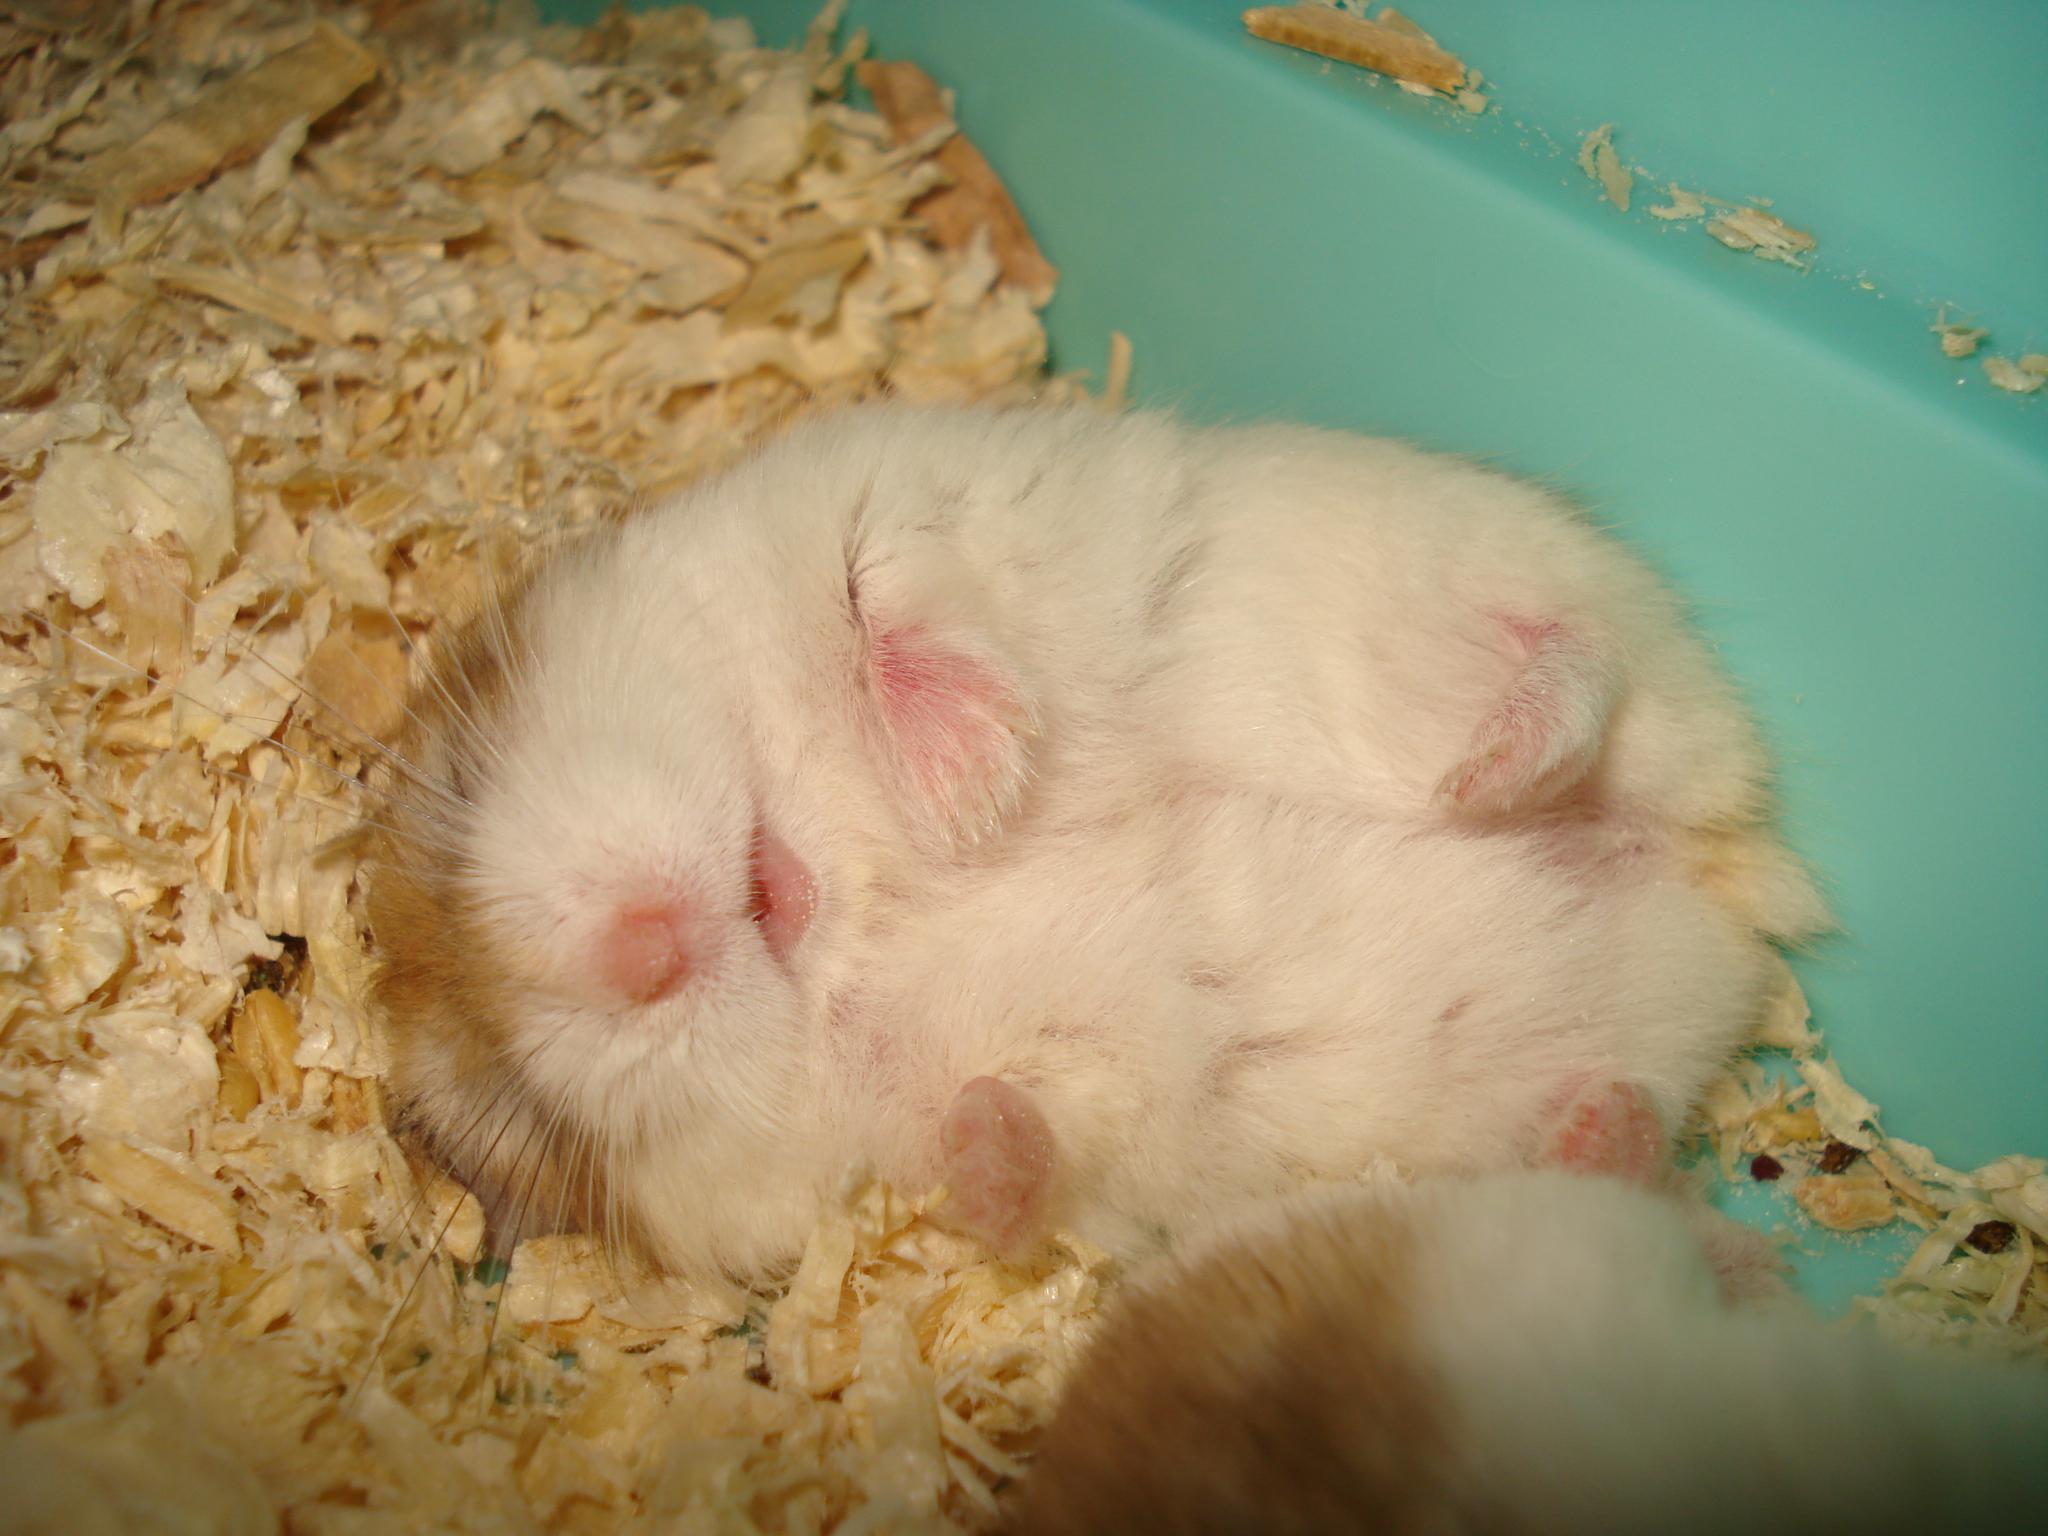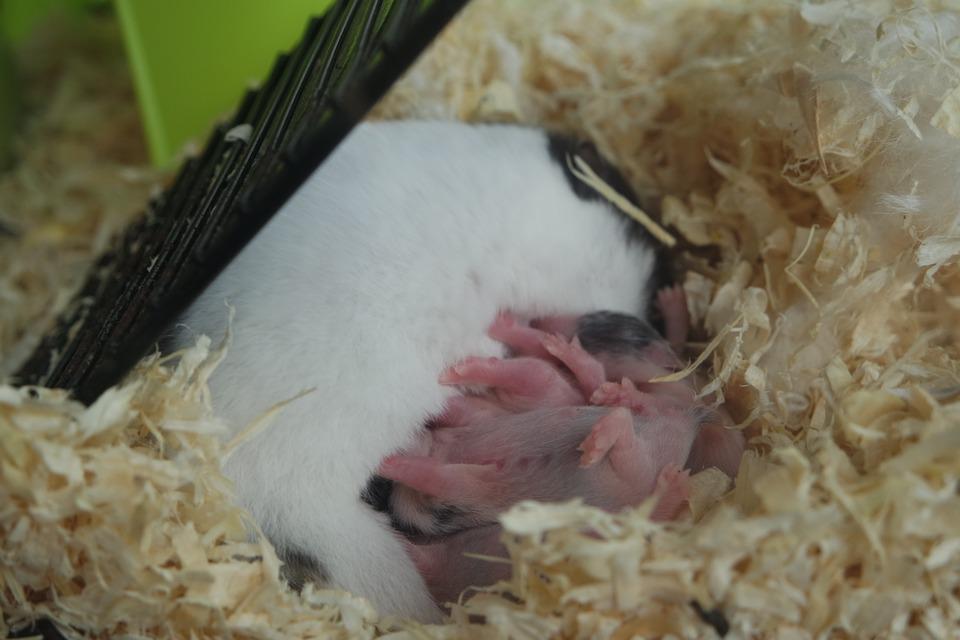The first image is the image on the left, the second image is the image on the right. For the images shown, is this caption "An image shows the white-furred belly of a hamster on its back with all four paws in the air." true? Answer yes or no. Yes. The first image is the image on the left, the second image is the image on the right. Evaluate the accuracy of this statement regarding the images: "There is a tiny mammal in a human hand.". Is it true? Answer yes or no. No. 